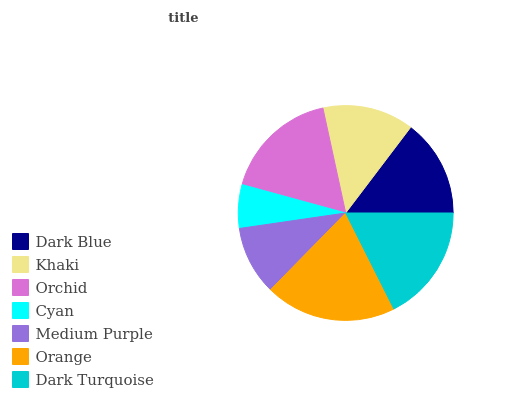Is Cyan the minimum?
Answer yes or no. Yes. Is Orange the maximum?
Answer yes or no. Yes. Is Khaki the minimum?
Answer yes or no. No. Is Khaki the maximum?
Answer yes or no. No. Is Dark Blue greater than Khaki?
Answer yes or no. Yes. Is Khaki less than Dark Blue?
Answer yes or no. Yes. Is Khaki greater than Dark Blue?
Answer yes or no. No. Is Dark Blue less than Khaki?
Answer yes or no. No. Is Dark Blue the high median?
Answer yes or no. Yes. Is Dark Blue the low median?
Answer yes or no. Yes. Is Dark Turquoise the high median?
Answer yes or no. No. Is Cyan the low median?
Answer yes or no. No. 